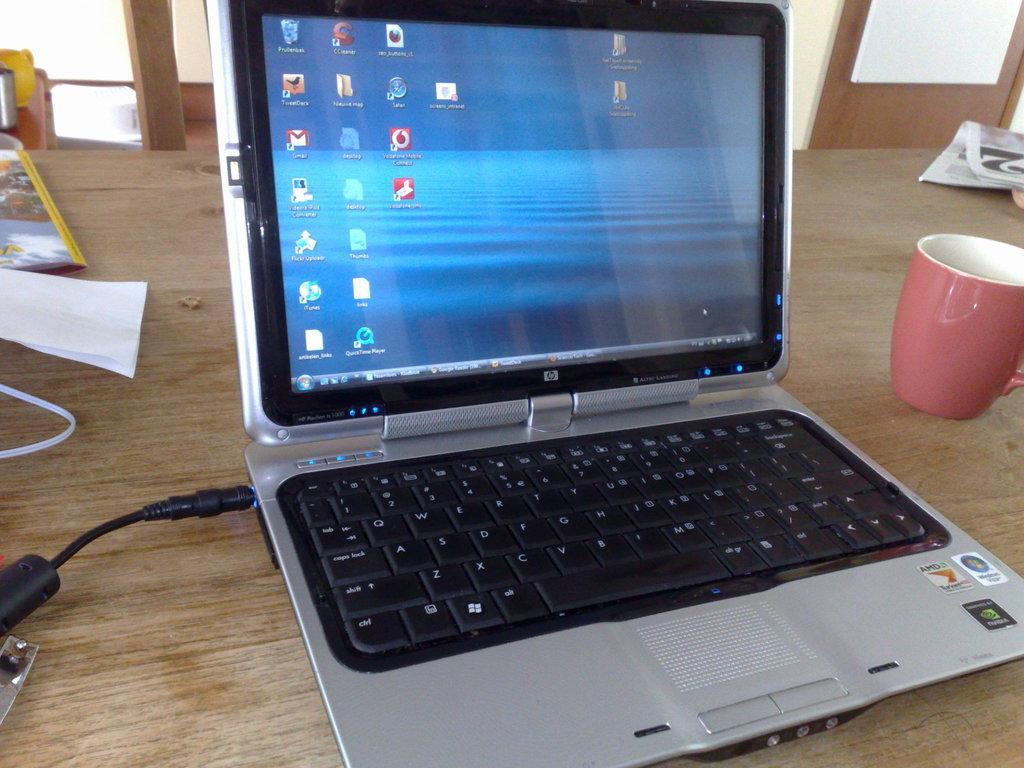Describe this image in one or two sentences. In this picture there is a table, on the table there are newspaper, cup, laptop, cable, paper and book. In the background there is a door and wall. 